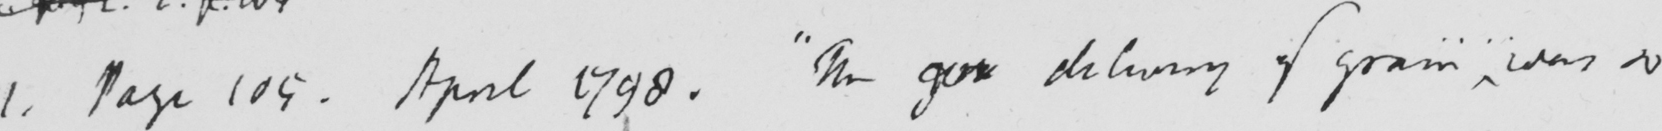What is written in this line of handwriting? 1 . Page 109 . April 1798 .  " The  <gap/>  delivery of grain was so 